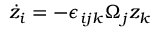<formula> <loc_0><loc_0><loc_500><loc_500>\dot { z } _ { i } = - \epsilon _ { i j k } \Omega _ { j } z _ { k }</formula> 